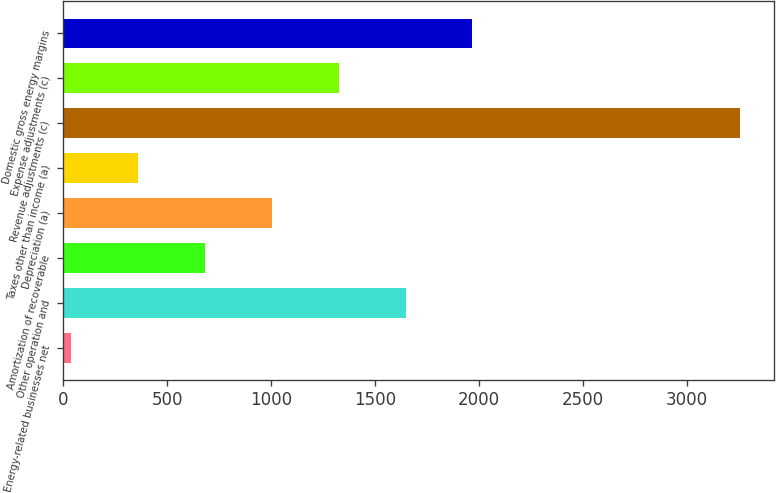<chart> <loc_0><loc_0><loc_500><loc_500><bar_chart><fcel>Energy-related businesses net<fcel>Other operation and<fcel>Amortization of recoverable<fcel>Depreciation (a)<fcel>Taxes other than income (a)<fcel>Revenue adjustments (c)<fcel>Expense adjustments (c)<fcel>Domestic gross energy margins<nl><fcel>38<fcel>1647<fcel>681.6<fcel>1003.4<fcel>359.8<fcel>3256<fcel>1325.2<fcel>1968.8<nl></chart> 